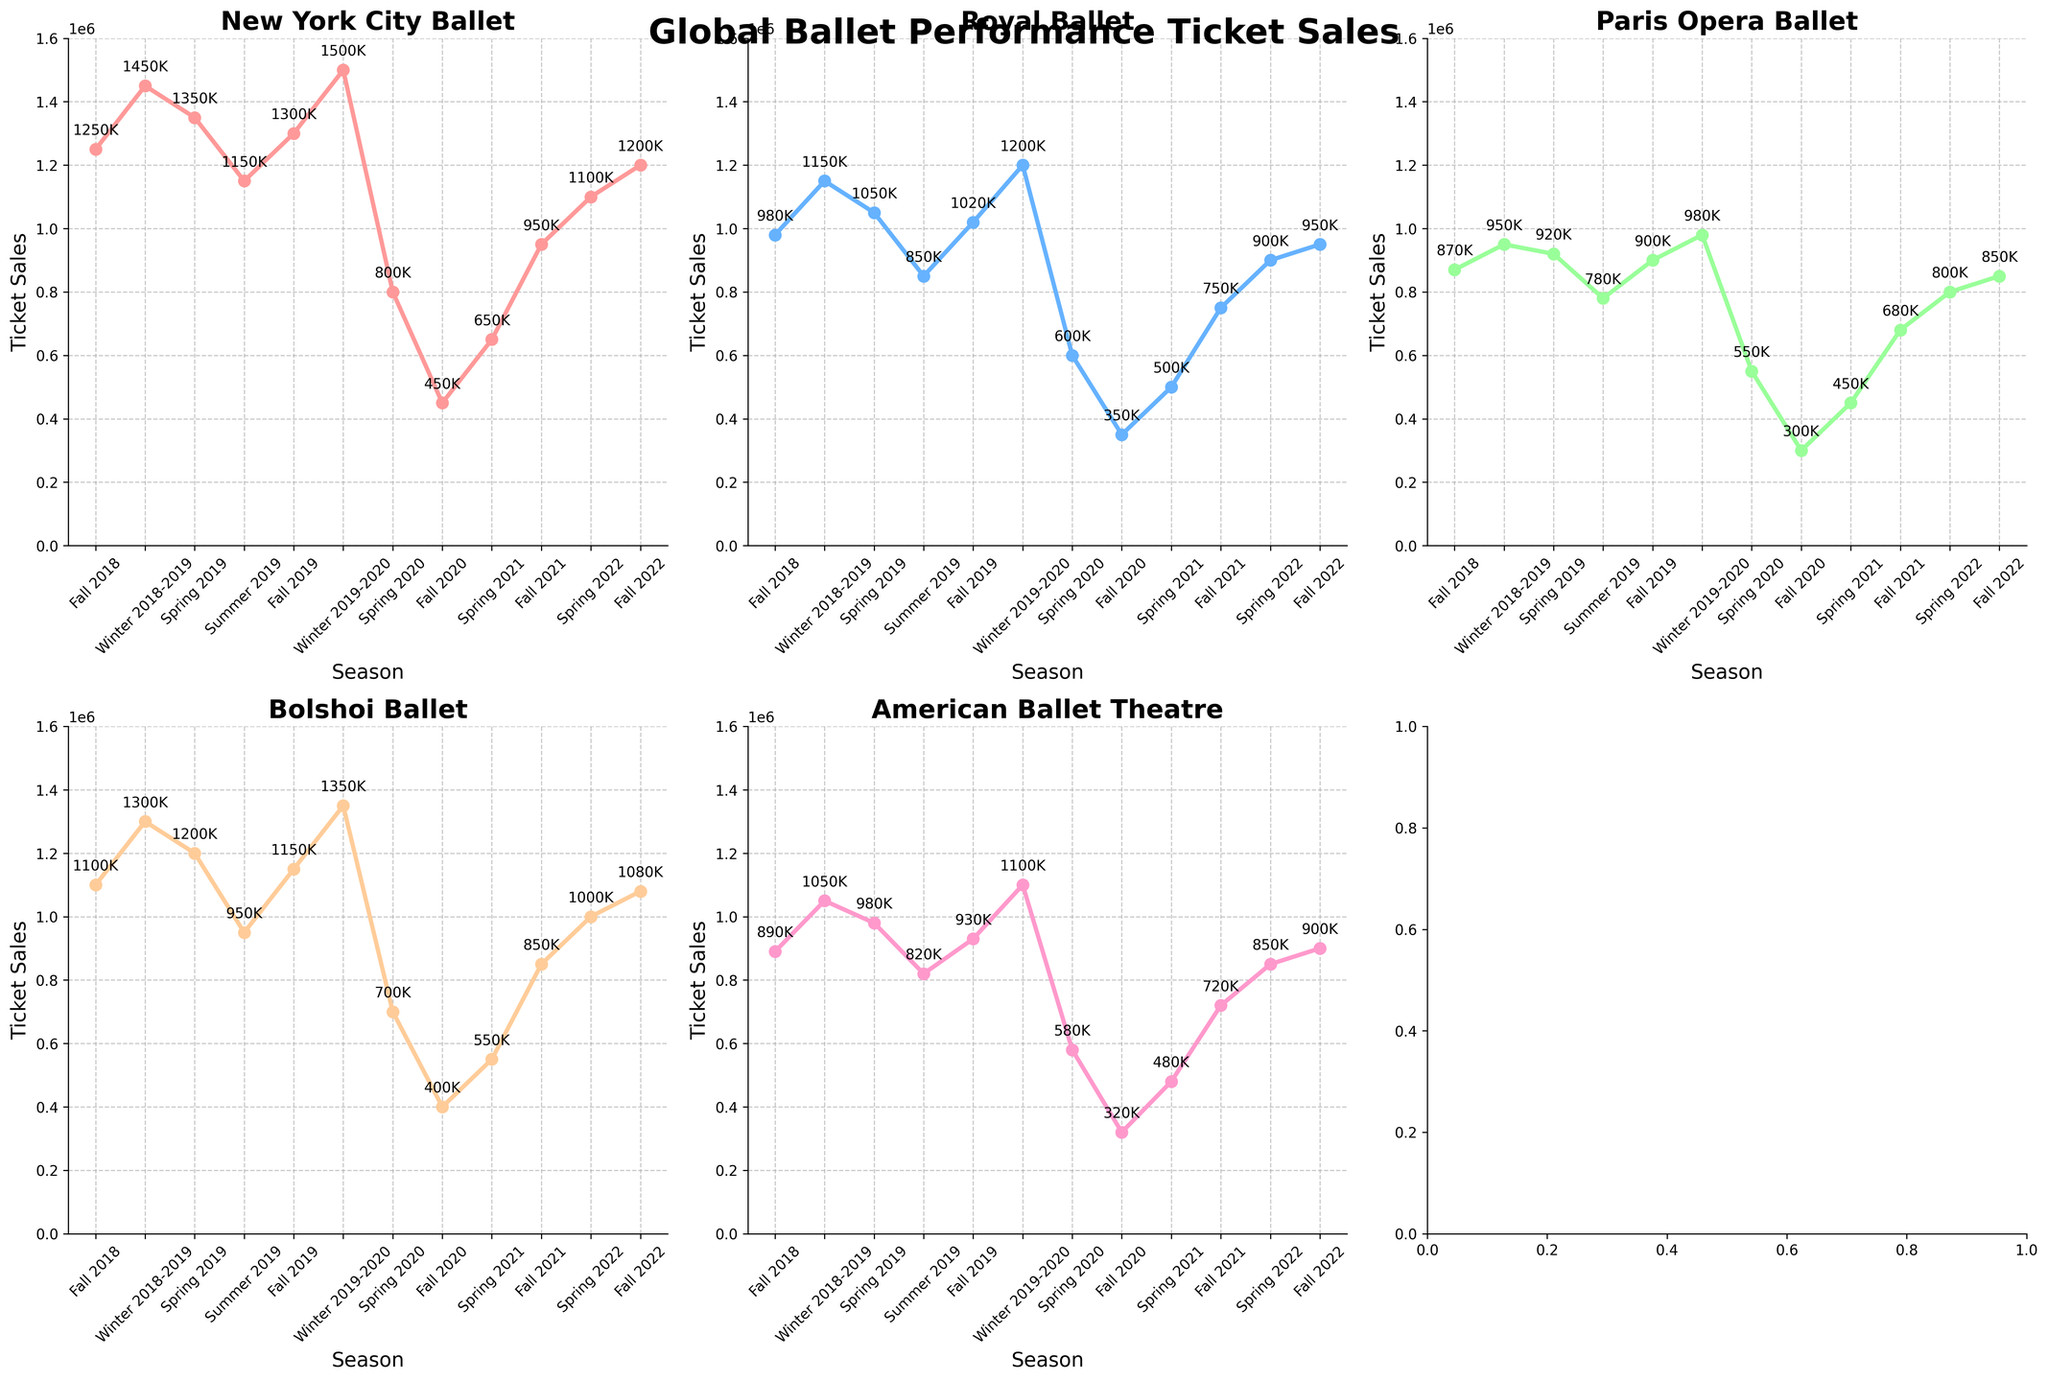What is the title of the figure? The title of the figure is displayed at the top. It is a brief summary of what the entire figure represents.
Answer: Global Ballet Performance Ticket Sales How many ticket sales trajectories are shown in the entire set of subplots? Each subplot represents a ballet company with its ticket sales trajectory over different seasons. Counting each subplot, there are 5 different companies.
Answer: 5 Which ballet company had the highest ticket sales during Winter 2019-2020? By looking at the subplot for Winter 2019-2020, we can compare the ticket sales marks. The New York City Ballet had the highest ticket sales during this period.
Answer: New York City Ballet What colors are used to represent each ballet company in the subplots? The colors in the subplots uniquely identify each ballet company. New York City Ballet is in a red shade, Royal Ballet in blue, Paris Opera Ballet in green, Bolshoi Ballet in orange, and American Ballet Theatre in pink.
Answer: Red, Blue, Green, Orange, Pink Which season typically has the lowest ticket sales for all companies? By observing the trends across all subplots, the lowest ticket numbers for each intersect mostly during Fall 2020.
Answer: Fall 2020 Comparing New York City Ballet and Royal Ballet, which company showed a steeper decline in ticket sales from Winter 2019-2020 to Spring 2020? We need to determine the difference between Winter 2019-2020 and Spring 2020 for each company: New York City Ballet went from 1,500,000 to 800,000 (-700,000) and Royal Ballet went from 1,200,000 to 600,000 (-600,000). New York City Ballet had a steeper decline.
Answer: New York City Ballet What was the average ticket sales for the Paris Opera Ballet over the Spring seasons? Calculate the average for Paris Opera Ballet's ticket sales during Spring (2019, 2020, 2021, 2022). Summing these values gives 920,000 + 550,000 + 450,000 + 800,000 = 2,720,000. Dividing by 4 gives us the average of 680,000.
Answer: 680,000 Between Fall 2018 and Fall 2019, did the Bolshoi Ballet see an increase or decrease in ticket sales? Comparing the ticket sales of Fall 2018 (1,100,000) with Fall 2019 (1,150,000), there is an increase in ticket sales.
Answer: Increase Identify the season with the highest ticket sales for the American Ballet Theatre. Look at the peaks in the American Ballet Theatre subplot. The highest ticket sales occur during Winter 2019-2020.
Answer: Winter 2019-2020 What is the trend in ticket sales for the Royal Ballet from Fall 2020 to Fall 2022? Observing the Royal Ballet subplot, we see a gradual increase in ticket sales from Fall 2020 (350,000) through Fall 2021 (750,000) to Fall 2022 (950,000).
Answer: Increasing 